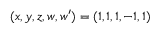<formula> <loc_0><loc_0><loc_500><loc_500>( x , y , z , w , w ^ { \prime } ) = ( 1 , 1 , 1 , - 1 , 1 )</formula> 